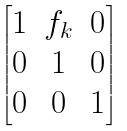Convert formula to latex. <formula><loc_0><loc_0><loc_500><loc_500>\begin{bmatrix} 1 & f _ { k } & 0 \\ 0 & 1 & 0 \\ 0 & 0 & 1 \end{bmatrix}</formula> 